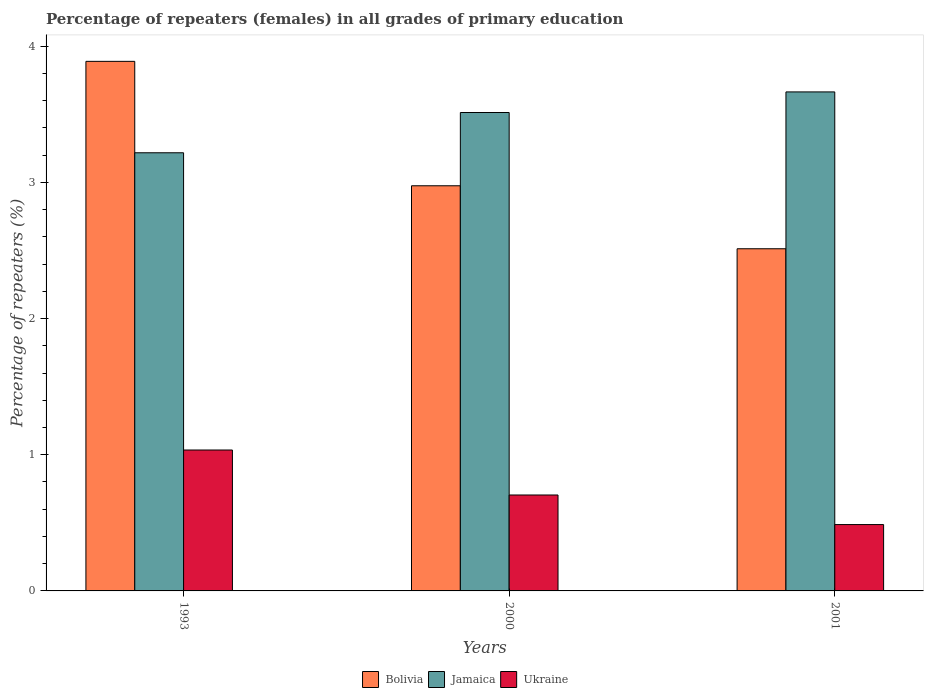How many bars are there on the 1st tick from the left?
Keep it short and to the point. 3. How many bars are there on the 3rd tick from the right?
Keep it short and to the point. 3. What is the percentage of repeaters (females) in Jamaica in 2001?
Your answer should be very brief. 3.66. Across all years, what is the maximum percentage of repeaters (females) in Bolivia?
Make the answer very short. 3.89. Across all years, what is the minimum percentage of repeaters (females) in Jamaica?
Ensure brevity in your answer.  3.22. What is the total percentage of repeaters (females) in Ukraine in the graph?
Provide a succinct answer. 2.23. What is the difference between the percentage of repeaters (females) in Jamaica in 1993 and that in 2001?
Keep it short and to the point. -0.45. What is the difference between the percentage of repeaters (females) in Bolivia in 1993 and the percentage of repeaters (females) in Jamaica in 2001?
Make the answer very short. 0.22. What is the average percentage of repeaters (females) in Jamaica per year?
Your answer should be very brief. 3.46. In the year 2001, what is the difference between the percentage of repeaters (females) in Jamaica and percentage of repeaters (females) in Bolivia?
Give a very brief answer. 1.15. What is the ratio of the percentage of repeaters (females) in Ukraine in 1993 to that in 2001?
Keep it short and to the point. 2.12. Is the percentage of repeaters (females) in Bolivia in 1993 less than that in 2000?
Your answer should be compact. No. What is the difference between the highest and the second highest percentage of repeaters (females) in Ukraine?
Make the answer very short. 0.33. What is the difference between the highest and the lowest percentage of repeaters (females) in Ukraine?
Your answer should be very brief. 0.55. In how many years, is the percentage of repeaters (females) in Ukraine greater than the average percentage of repeaters (females) in Ukraine taken over all years?
Your answer should be very brief. 1. Is the sum of the percentage of repeaters (females) in Jamaica in 1993 and 2000 greater than the maximum percentage of repeaters (females) in Ukraine across all years?
Make the answer very short. Yes. What does the 3rd bar from the left in 2000 represents?
Ensure brevity in your answer.  Ukraine. What does the 2nd bar from the right in 2000 represents?
Give a very brief answer. Jamaica. Does the graph contain any zero values?
Offer a terse response. No. How are the legend labels stacked?
Give a very brief answer. Horizontal. What is the title of the graph?
Your response must be concise. Percentage of repeaters (females) in all grades of primary education. What is the label or title of the X-axis?
Offer a terse response. Years. What is the label or title of the Y-axis?
Keep it short and to the point. Percentage of repeaters (%). What is the Percentage of repeaters (%) of Bolivia in 1993?
Ensure brevity in your answer.  3.89. What is the Percentage of repeaters (%) of Jamaica in 1993?
Your answer should be compact. 3.22. What is the Percentage of repeaters (%) of Ukraine in 1993?
Give a very brief answer. 1.03. What is the Percentage of repeaters (%) in Bolivia in 2000?
Give a very brief answer. 2.97. What is the Percentage of repeaters (%) of Jamaica in 2000?
Your answer should be compact. 3.51. What is the Percentage of repeaters (%) of Ukraine in 2000?
Give a very brief answer. 0.7. What is the Percentage of repeaters (%) of Bolivia in 2001?
Give a very brief answer. 2.51. What is the Percentage of repeaters (%) of Jamaica in 2001?
Ensure brevity in your answer.  3.66. What is the Percentage of repeaters (%) of Ukraine in 2001?
Ensure brevity in your answer.  0.49. Across all years, what is the maximum Percentage of repeaters (%) in Bolivia?
Ensure brevity in your answer.  3.89. Across all years, what is the maximum Percentage of repeaters (%) of Jamaica?
Provide a short and direct response. 3.66. Across all years, what is the maximum Percentage of repeaters (%) of Ukraine?
Ensure brevity in your answer.  1.03. Across all years, what is the minimum Percentage of repeaters (%) of Bolivia?
Make the answer very short. 2.51. Across all years, what is the minimum Percentage of repeaters (%) of Jamaica?
Keep it short and to the point. 3.22. Across all years, what is the minimum Percentage of repeaters (%) in Ukraine?
Provide a succinct answer. 0.49. What is the total Percentage of repeaters (%) in Bolivia in the graph?
Your response must be concise. 9.38. What is the total Percentage of repeaters (%) of Jamaica in the graph?
Your response must be concise. 10.39. What is the total Percentage of repeaters (%) in Ukraine in the graph?
Offer a very short reply. 2.23. What is the difference between the Percentage of repeaters (%) in Bolivia in 1993 and that in 2000?
Your response must be concise. 0.91. What is the difference between the Percentage of repeaters (%) in Jamaica in 1993 and that in 2000?
Make the answer very short. -0.3. What is the difference between the Percentage of repeaters (%) of Ukraine in 1993 and that in 2000?
Ensure brevity in your answer.  0.33. What is the difference between the Percentage of repeaters (%) of Bolivia in 1993 and that in 2001?
Ensure brevity in your answer.  1.38. What is the difference between the Percentage of repeaters (%) of Jamaica in 1993 and that in 2001?
Make the answer very short. -0.45. What is the difference between the Percentage of repeaters (%) in Ukraine in 1993 and that in 2001?
Offer a very short reply. 0.55. What is the difference between the Percentage of repeaters (%) in Bolivia in 2000 and that in 2001?
Ensure brevity in your answer.  0.46. What is the difference between the Percentage of repeaters (%) in Jamaica in 2000 and that in 2001?
Keep it short and to the point. -0.15. What is the difference between the Percentage of repeaters (%) in Ukraine in 2000 and that in 2001?
Provide a short and direct response. 0.22. What is the difference between the Percentage of repeaters (%) of Bolivia in 1993 and the Percentage of repeaters (%) of Jamaica in 2000?
Your answer should be very brief. 0.38. What is the difference between the Percentage of repeaters (%) of Bolivia in 1993 and the Percentage of repeaters (%) of Ukraine in 2000?
Provide a short and direct response. 3.18. What is the difference between the Percentage of repeaters (%) in Jamaica in 1993 and the Percentage of repeaters (%) in Ukraine in 2000?
Offer a terse response. 2.51. What is the difference between the Percentage of repeaters (%) in Bolivia in 1993 and the Percentage of repeaters (%) in Jamaica in 2001?
Provide a short and direct response. 0.22. What is the difference between the Percentage of repeaters (%) in Bolivia in 1993 and the Percentage of repeaters (%) in Ukraine in 2001?
Your answer should be compact. 3.4. What is the difference between the Percentage of repeaters (%) in Jamaica in 1993 and the Percentage of repeaters (%) in Ukraine in 2001?
Your answer should be compact. 2.73. What is the difference between the Percentage of repeaters (%) in Bolivia in 2000 and the Percentage of repeaters (%) in Jamaica in 2001?
Give a very brief answer. -0.69. What is the difference between the Percentage of repeaters (%) of Bolivia in 2000 and the Percentage of repeaters (%) of Ukraine in 2001?
Make the answer very short. 2.49. What is the difference between the Percentage of repeaters (%) in Jamaica in 2000 and the Percentage of repeaters (%) in Ukraine in 2001?
Offer a terse response. 3.03. What is the average Percentage of repeaters (%) of Bolivia per year?
Provide a succinct answer. 3.12. What is the average Percentage of repeaters (%) of Jamaica per year?
Offer a very short reply. 3.46. What is the average Percentage of repeaters (%) in Ukraine per year?
Provide a short and direct response. 0.74. In the year 1993, what is the difference between the Percentage of repeaters (%) of Bolivia and Percentage of repeaters (%) of Jamaica?
Your response must be concise. 0.67. In the year 1993, what is the difference between the Percentage of repeaters (%) in Bolivia and Percentage of repeaters (%) in Ukraine?
Keep it short and to the point. 2.85. In the year 1993, what is the difference between the Percentage of repeaters (%) of Jamaica and Percentage of repeaters (%) of Ukraine?
Your response must be concise. 2.18. In the year 2000, what is the difference between the Percentage of repeaters (%) of Bolivia and Percentage of repeaters (%) of Jamaica?
Make the answer very short. -0.54. In the year 2000, what is the difference between the Percentage of repeaters (%) in Bolivia and Percentage of repeaters (%) in Ukraine?
Provide a succinct answer. 2.27. In the year 2000, what is the difference between the Percentage of repeaters (%) of Jamaica and Percentage of repeaters (%) of Ukraine?
Provide a short and direct response. 2.81. In the year 2001, what is the difference between the Percentage of repeaters (%) in Bolivia and Percentage of repeaters (%) in Jamaica?
Offer a terse response. -1.15. In the year 2001, what is the difference between the Percentage of repeaters (%) in Bolivia and Percentage of repeaters (%) in Ukraine?
Offer a terse response. 2.03. In the year 2001, what is the difference between the Percentage of repeaters (%) in Jamaica and Percentage of repeaters (%) in Ukraine?
Your answer should be very brief. 3.18. What is the ratio of the Percentage of repeaters (%) of Bolivia in 1993 to that in 2000?
Give a very brief answer. 1.31. What is the ratio of the Percentage of repeaters (%) of Jamaica in 1993 to that in 2000?
Ensure brevity in your answer.  0.92. What is the ratio of the Percentage of repeaters (%) in Ukraine in 1993 to that in 2000?
Offer a very short reply. 1.47. What is the ratio of the Percentage of repeaters (%) of Bolivia in 1993 to that in 2001?
Your answer should be compact. 1.55. What is the ratio of the Percentage of repeaters (%) in Jamaica in 1993 to that in 2001?
Your answer should be compact. 0.88. What is the ratio of the Percentage of repeaters (%) in Ukraine in 1993 to that in 2001?
Offer a very short reply. 2.12. What is the ratio of the Percentage of repeaters (%) of Bolivia in 2000 to that in 2001?
Ensure brevity in your answer.  1.18. What is the ratio of the Percentage of repeaters (%) of Jamaica in 2000 to that in 2001?
Make the answer very short. 0.96. What is the ratio of the Percentage of repeaters (%) of Ukraine in 2000 to that in 2001?
Keep it short and to the point. 1.45. What is the difference between the highest and the second highest Percentage of repeaters (%) of Bolivia?
Provide a short and direct response. 0.91. What is the difference between the highest and the second highest Percentage of repeaters (%) of Jamaica?
Your response must be concise. 0.15. What is the difference between the highest and the second highest Percentage of repeaters (%) in Ukraine?
Give a very brief answer. 0.33. What is the difference between the highest and the lowest Percentage of repeaters (%) of Bolivia?
Offer a very short reply. 1.38. What is the difference between the highest and the lowest Percentage of repeaters (%) in Jamaica?
Provide a short and direct response. 0.45. What is the difference between the highest and the lowest Percentage of repeaters (%) of Ukraine?
Your answer should be very brief. 0.55. 